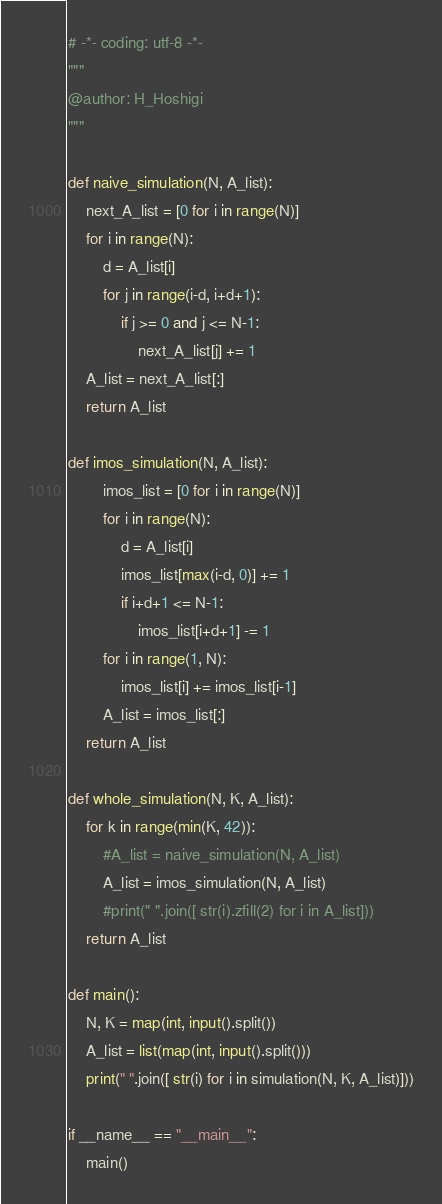<code> <loc_0><loc_0><loc_500><loc_500><_Python_># -*- coding: utf-8 -*-
"""
@author: H_Hoshigi
"""

def naive_simulation(N, A_list):
    next_A_list = [0 for i in range(N)]
    for i in range(N):
        d = A_list[i]
        for j in range(i-d, i+d+1):
            if j >= 0 and j <= N-1:
                next_A_list[j] += 1
    A_list = next_A_list[:]
    return A_list

def imos_simulation(N, A_list):
        imos_list = [0 for i in range(N)]
        for i in range(N):
            d = A_list[i]
            imos_list[max(i-d, 0)] += 1
            if i+d+1 <= N-1:
                imos_list[i+d+1] -= 1
        for i in range(1, N):
            imos_list[i] += imos_list[i-1]
        A_list = imos_list[:]
    return A_list

def whole_simulation(N, K, A_list):
    for k in range(min(K, 42)):
        #A_list = naive_simulation(N, A_list)
        A_list = imos_simulation(N, A_list)
        #print(" ".join([ str(i).zfill(2) for i in A_list]))
    return A_list

def main():
    N, K = map(int, input().split())
    A_list = list(map(int, input().split()))
    print(" ".join([ str(i) for i in simulation(N, K, A_list)]))

if __name__ == "__main__":
    main()

</code> 